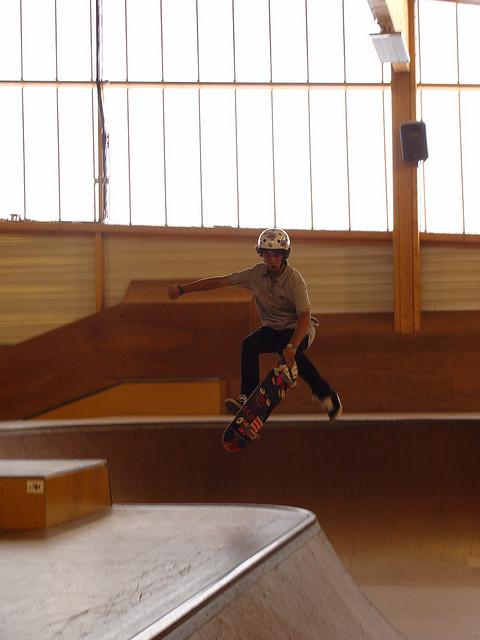What shape are the windows?
Short answer required. Rectangle. Where is the boy skateboarding?
Be succinct. Inside. Is he wearing a helmet?
Give a very brief answer. Yes. 